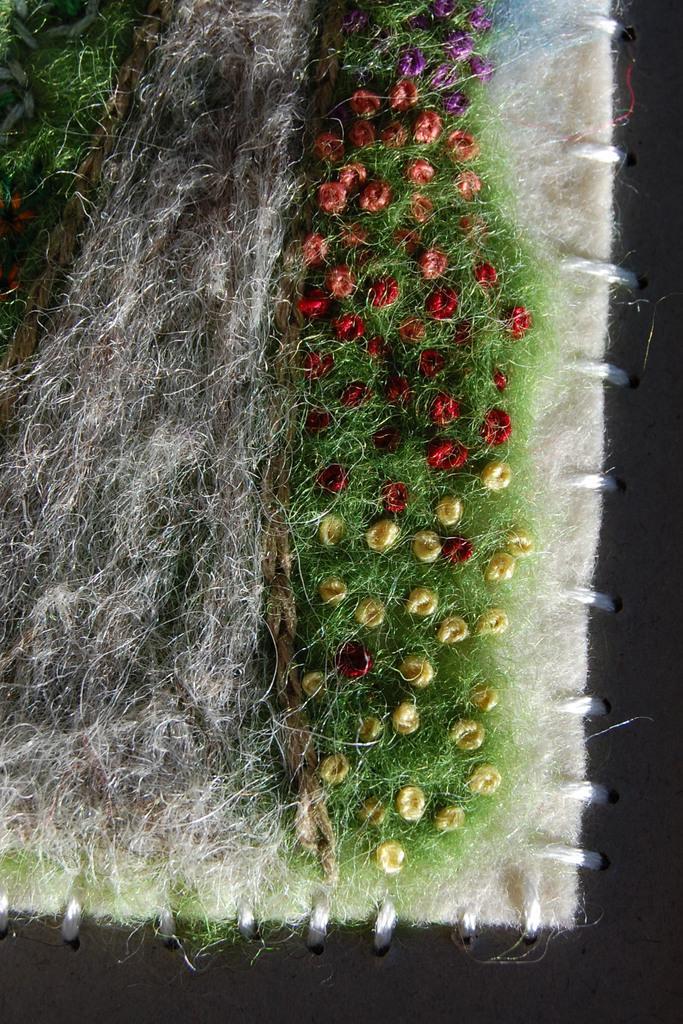Can you describe this image briefly? As we can see in the image there is dry grass and flowers. 